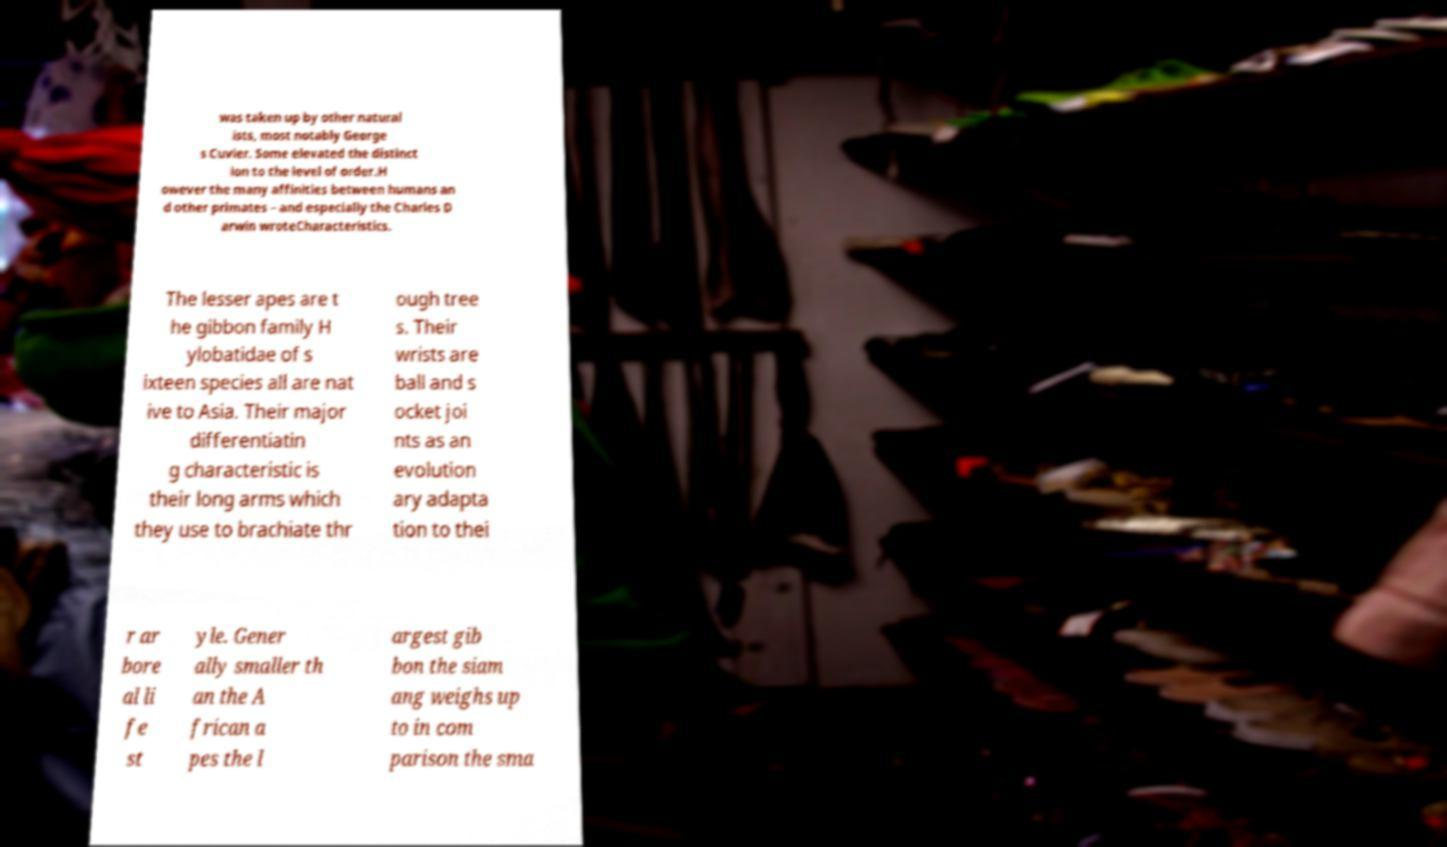Please identify and transcribe the text found in this image. was taken up by other natural ists, most notably George s Cuvier. Some elevated the distinct ion to the level of order.H owever the many affinities between humans an d other primates – and especially the Charles D arwin wroteCharacteristics. The lesser apes are t he gibbon family H ylobatidae of s ixteen species all are nat ive to Asia. Their major differentiatin g characteristic is their long arms which they use to brachiate thr ough tree s. Their wrists are ball and s ocket joi nts as an evolution ary adapta tion to thei r ar bore al li fe st yle. Gener ally smaller th an the A frican a pes the l argest gib bon the siam ang weighs up to in com parison the sma 